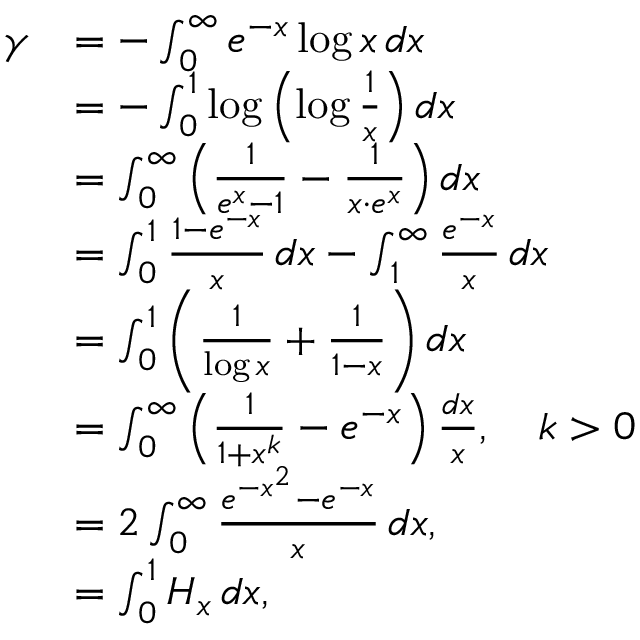Convert formula to latex. <formula><loc_0><loc_0><loc_500><loc_500>{ \begin{array} { r l } { \gamma } & { = - \int _ { 0 } ^ { \infty } e ^ { - x } \log x \, d x } \\ & { = - \int _ { 0 } ^ { 1 } \log \left ( \log { \frac { 1 } { x } } \right ) d x } \\ & { = \int _ { 0 } ^ { \infty } \left ( { \frac { 1 } { e ^ { x } - 1 } } - { \frac { 1 } { x \cdot e ^ { x } } } \right ) d x } \\ & { = \int _ { 0 } ^ { 1 } { \frac { 1 - e ^ { - x } } { x } } \, d x - \int _ { 1 } ^ { \infty } { \frac { e ^ { - x } } { x } } \, d x } \\ & { = \int _ { 0 } ^ { 1 } \left ( { \frac { 1 } { \log x } } + { \frac { 1 } { 1 - x } } \right ) d x } \\ & { = \int _ { 0 } ^ { \infty } \left ( { \frac { 1 } { 1 + x ^ { k } } } - e ^ { - x } \right ) { \frac { d x } { x } } , \quad k > 0 } \\ & { = 2 \int _ { 0 } ^ { \infty } { \frac { e ^ { - x ^ { 2 } } - e ^ { - x } } { x } } \, d x , } \\ & { = \int _ { 0 } ^ { 1 } H _ { x } \, d x , } \end{array} }</formula> 